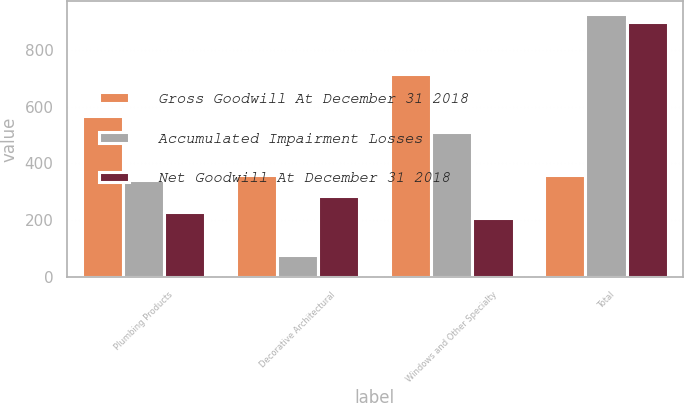Convert chart. <chart><loc_0><loc_0><loc_500><loc_500><stacked_bar_chart><ecel><fcel>Plumbing Products<fcel>Decorative Architectural<fcel>Windows and Other Specialty<fcel>Total<nl><fcel>Gross Goodwill At December 31 2018<fcel>568<fcel>358<fcel>717<fcel>358<nl><fcel>Accumulated Impairment Losses<fcel>340<fcel>75<fcel>511<fcel>926<nl><fcel>Net Goodwill At December 31 2018<fcel>228<fcel>283<fcel>206<fcel>898<nl></chart> 